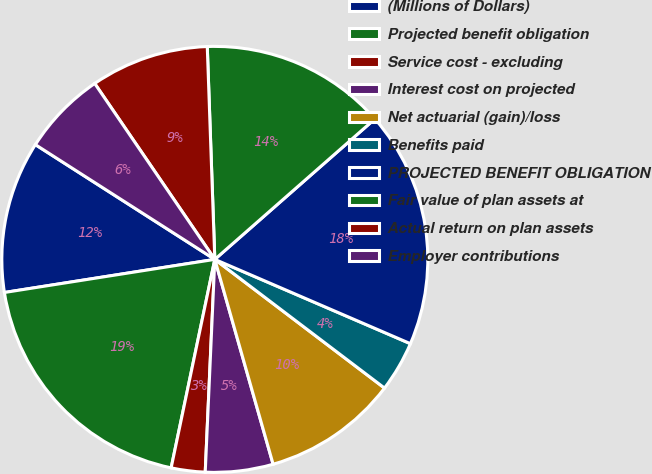Convert chart to OTSL. <chart><loc_0><loc_0><loc_500><loc_500><pie_chart><fcel>(Millions of Dollars)<fcel>Projected benefit obligation<fcel>Service cost - excluding<fcel>Interest cost on projected<fcel>Net actuarial (gain)/loss<fcel>Benefits paid<fcel>PROJECTED BENEFIT OBLIGATION<fcel>Fair value of plan assets at<fcel>Actual return on plan assets<fcel>Employer contributions<nl><fcel>11.54%<fcel>19.23%<fcel>2.57%<fcel>5.13%<fcel>10.26%<fcel>3.85%<fcel>17.94%<fcel>14.1%<fcel>8.97%<fcel>6.41%<nl></chart> 